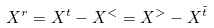<formula> <loc_0><loc_0><loc_500><loc_500>X ^ { r } = X ^ { t } - X ^ { < } = X ^ { > } - X ^ { \tilde { t } }</formula> 